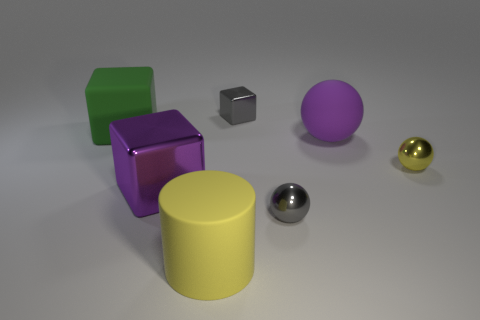What is the color of the big metal object?
Keep it short and to the point. Purple. The tiny metal object that is the same shape as the big shiny object is what color?
Offer a terse response. Gray. What number of other objects have the same shape as the small yellow object?
Provide a short and direct response. 2. What number of objects are either green matte blocks or big objects in front of the large green rubber block?
Your answer should be very brief. 4. Does the large sphere have the same color as the big cube in front of the purple ball?
Your response must be concise. Yes. What is the size of the block that is behind the purple metallic block and on the right side of the big green object?
Your response must be concise. Small. There is a large ball; are there any tiny yellow shiny spheres in front of it?
Your answer should be very brief. Yes. There is a tiny sphere behind the gray shiny ball; is there a purple object that is in front of it?
Give a very brief answer. Yes. Are there the same number of gray things in front of the green rubber object and gray metal objects that are behind the large shiny block?
Make the answer very short. Yes. What is the color of the cube that is the same material as the large purple ball?
Give a very brief answer. Green. 